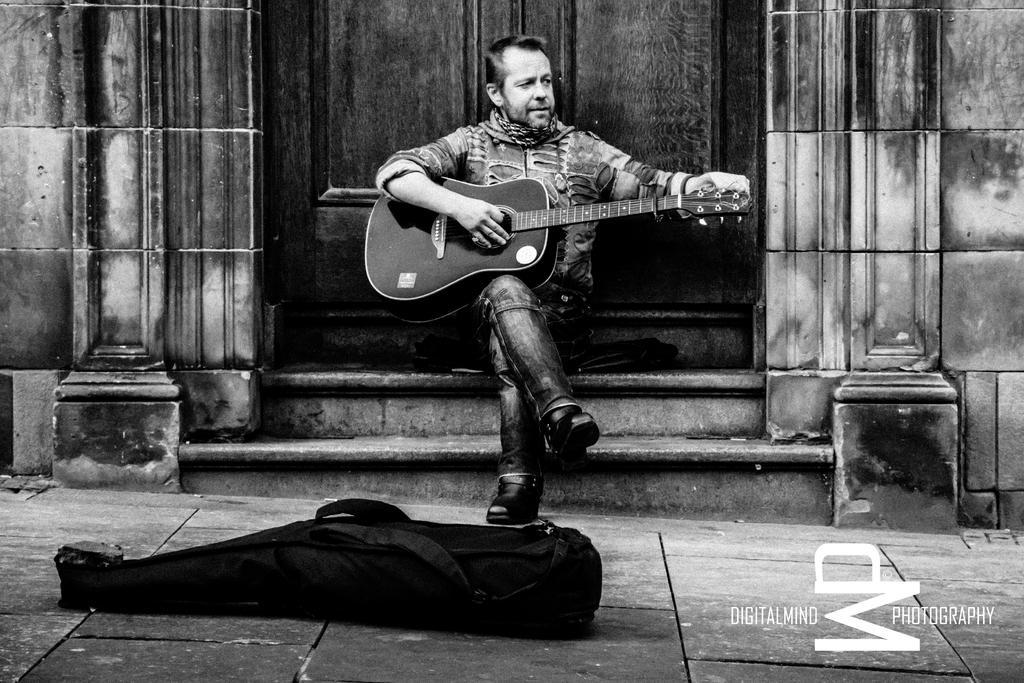How would you summarize this image in a sentence or two? This looks like a black and white image. There is a man sitting and playing guitar. This is a guitar bag lying on the floor. At background I can see a wooden door and these are stairs. 